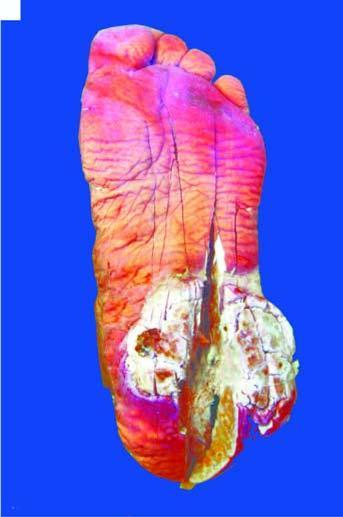what does the skin surface on the sole of the foot show?
Answer the question using a single word or phrase. A fungating and ulcerated growth 